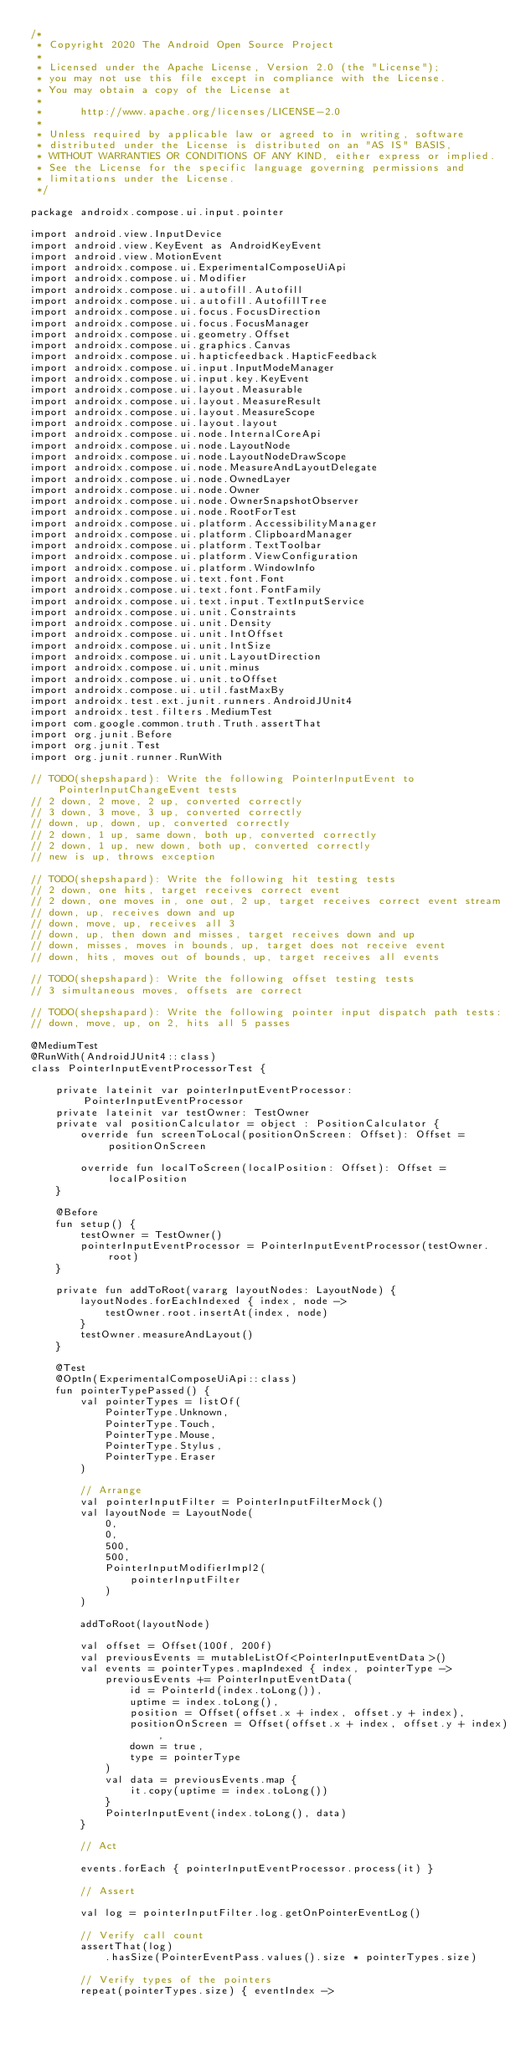Convert code to text. <code><loc_0><loc_0><loc_500><loc_500><_Kotlin_>/*
 * Copyright 2020 The Android Open Source Project
 *
 * Licensed under the Apache License, Version 2.0 (the "License");
 * you may not use this file except in compliance with the License.
 * You may obtain a copy of the License at
 *
 *      http://www.apache.org/licenses/LICENSE-2.0
 *
 * Unless required by applicable law or agreed to in writing, software
 * distributed under the License is distributed on an "AS IS" BASIS,
 * WITHOUT WARRANTIES OR CONDITIONS OF ANY KIND, either express or implied.
 * See the License for the specific language governing permissions and
 * limitations under the License.
 */

package androidx.compose.ui.input.pointer

import android.view.InputDevice
import android.view.KeyEvent as AndroidKeyEvent
import android.view.MotionEvent
import androidx.compose.ui.ExperimentalComposeUiApi
import androidx.compose.ui.Modifier
import androidx.compose.ui.autofill.Autofill
import androidx.compose.ui.autofill.AutofillTree
import androidx.compose.ui.focus.FocusDirection
import androidx.compose.ui.focus.FocusManager
import androidx.compose.ui.geometry.Offset
import androidx.compose.ui.graphics.Canvas
import androidx.compose.ui.hapticfeedback.HapticFeedback
import androidx.compose.ui.input.InputModeManager
import androidx.compose.ui.input.key.KeyEvent
import androidx.compose.ui.layout.Measurable
import androidx.compose.ui.layout.MeasureResult
import androidx.compose.ui.layout.MeasureScope
import androidx.compose.ui.layout.layout
import androidx.compose.ui.node.InternalCoreApi
import androidx.compose.ui.node.LayoutNode
import androidx.compose.ui.node.LayoutNodeDrawScope
import androidx.compose.ui.node.MeasureAndLayoutDelegate
import androidx.compose.ui.node.OwnedLayer
import androidx.compose.ui.node.Owner
import androidx.compose.ui.node.OwnerSnapshotObserver
import androidx.compose.ui.node.RootForTest
import androidx.compose.ui.platform.AccessibilityManager
import androidx.compose.ui.platform.ClipboardManager
import androidx.compose.ui.platform.TextToolbar
import androidx.compose.ui.platform.ViewConfiguration
import androidx.compose.ui.platform.WindowInfo
import androidx.compose.ui.text.font.Font
import androidx.compose.ui.text.font.FontFamily
import androidx.compose.ui.text.input.TextInputService
import androidx.compose.ui.unit.Constraints
import androidx.compose.ui.unit.Density
import androidx.compose.ui.unit.IntOffset
import androidx.compose.ui.unit.IntSize
import androidx.compose.ui.unit.LayoutDirection
import androidx.compose.ui.unit.minus
import androidx.compose.ui.unit.toOffset
import androidx.compose.ui.util.fastMaxBy
import androidx.test.ext.junit.runners.AndroidJUnit4
import androidx.test.filters.MediumTest
import com.google.common.truth.Truth.assertThat
import org.junit.Before
import org.junit.Test
import org.junit.runner.RunWith

// TODO(shepshapard): Write the following PointerInputEvent to PointerInputChangeEvent tests
// 2 down, 2 move, 2 up, converted correctly
// 3 down, 3 move, 3 up, converted correctly
// down, up, down, up, converted correctly
// 2 down, 1 up, same down, both up, converted correctly
// 2 down, 1 up, new down, both up, converted correctly
// new is up, throws exception

// TODO(shepshapard): Write the following hit testing tests
// 2 down, one hits, target receives correct event
// 2 down, one moves in, one out, 2 up, target receives correct event stream
// down, up, receives down and up
// down, move, up, receives all 3
// down, up, then down and misses, target receives down and up
// down, misses, moves in bounds, up, target does not receive event
// down, hits, moves out of bounds, up, target receives all events

// TODO(shepshapard): Write the following offset testing tests
// 3 simultaneous moves, offsets are correct

// TODO(shepshapard): Write the following pointer input dispatch path tests:
// down, move, up, on 2, hits all 5 passes

@MediumTest
@RunWith(AndroidJUnit4::class)
class PointerInputEventProcessorTest {

    private lateinit var pointerInputEventProcessor: PointerInputEventProcessor
    private lateinit var testOwner: TestOwner
    private val positionCalculator = object : PositionCalculator {
        override fun screenToLocal(positionOnScreen: Offset): Offset = positionOnScreen

        override fun localToScreen(localPosition: Offset): Offset = localPosition
    }

    @Before
    fun setup() {
        testOwner = TestOwner()
        pointerInputEventProcessor = PointerInputEventProcessor(testOwner.root)
    }

    private fun addToRoot(vararg layoutNodes: LayoutNode) {
        layoutNodes.forEachIndexed { index, node ->
            testOwner.root.insertAt(index, node)
        }
        testOwner.measureAndLayout()
    }

    @Test
    @OptIn(ExperimentalComposeUiApi::class)
    fun pointerTypePassed() {
        val pointerTypes = listOf(
            PointerType.Unknown,
            PointerType.Touch,
            PointerType.Mouse,
            PointerType.Stylus,
            PointerType.Eraser
        )

        // Arrange
        val pointerInputFilter = PointerInputFilterMock()
        val layoutNode = LayoutNode(
            0,
            0,
            500,
            500,
            PointerInputModifierImpl2(
                pointerInputFilter
            )
        )

        addToRoot(layoutNode)

        val offset = Offset(100f, 200f)
        val previousEvents = mutableListOf<PointerInputEventData>()
        val events = pointerTypes.mapIndexed { index, pointerType ->
            previousEvents += PointerInputEventData(
                id = PointerId(index.toLong()),
                uptime = index.toLong(),
                position = Offset(offset.x + index, offset.y + index),
                positionOnScreen = Offset(offset.x + index, offset.y + index),
                down = true,
                type = pointerType
            )
            val data = previousEvents.map {
                it.copy(uptime = index.toLong())
            }
            PointerInputEvent(index.toLong(), data)
        }

        // Act

        events.forEach { pointerInputEventProcessor.process(it) }

        // Assert

        val log = pointerInputFilter.log.getOnPointerEventLog()

        // Verify call count
        assertThat(log)
            .hasSize(PointerEventPass.values().size * pointerTypes.size)

        // Verify types of the pointers
        repeat(pointerTypes.size) { eventIndex -></code> 